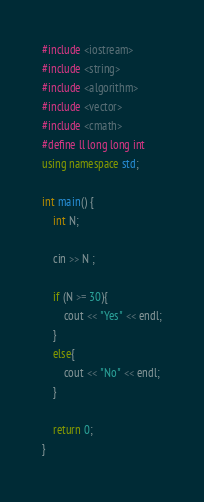Convert code to text. <code><loc_0><loc_0><loc_500><loc_500><_C++_>#include <iostream>
#include <string>
#include <algorithm>
#include <vector>
#include <cmath>
#define ll long long int
using namespace std;

int main() {
	int N;

	cin >> N ;

	if (N >= 30){
		cout << "Yes" << endl;
	}
	else{
		cout << "No" << endl;
	}

	return 0;
}</code> 